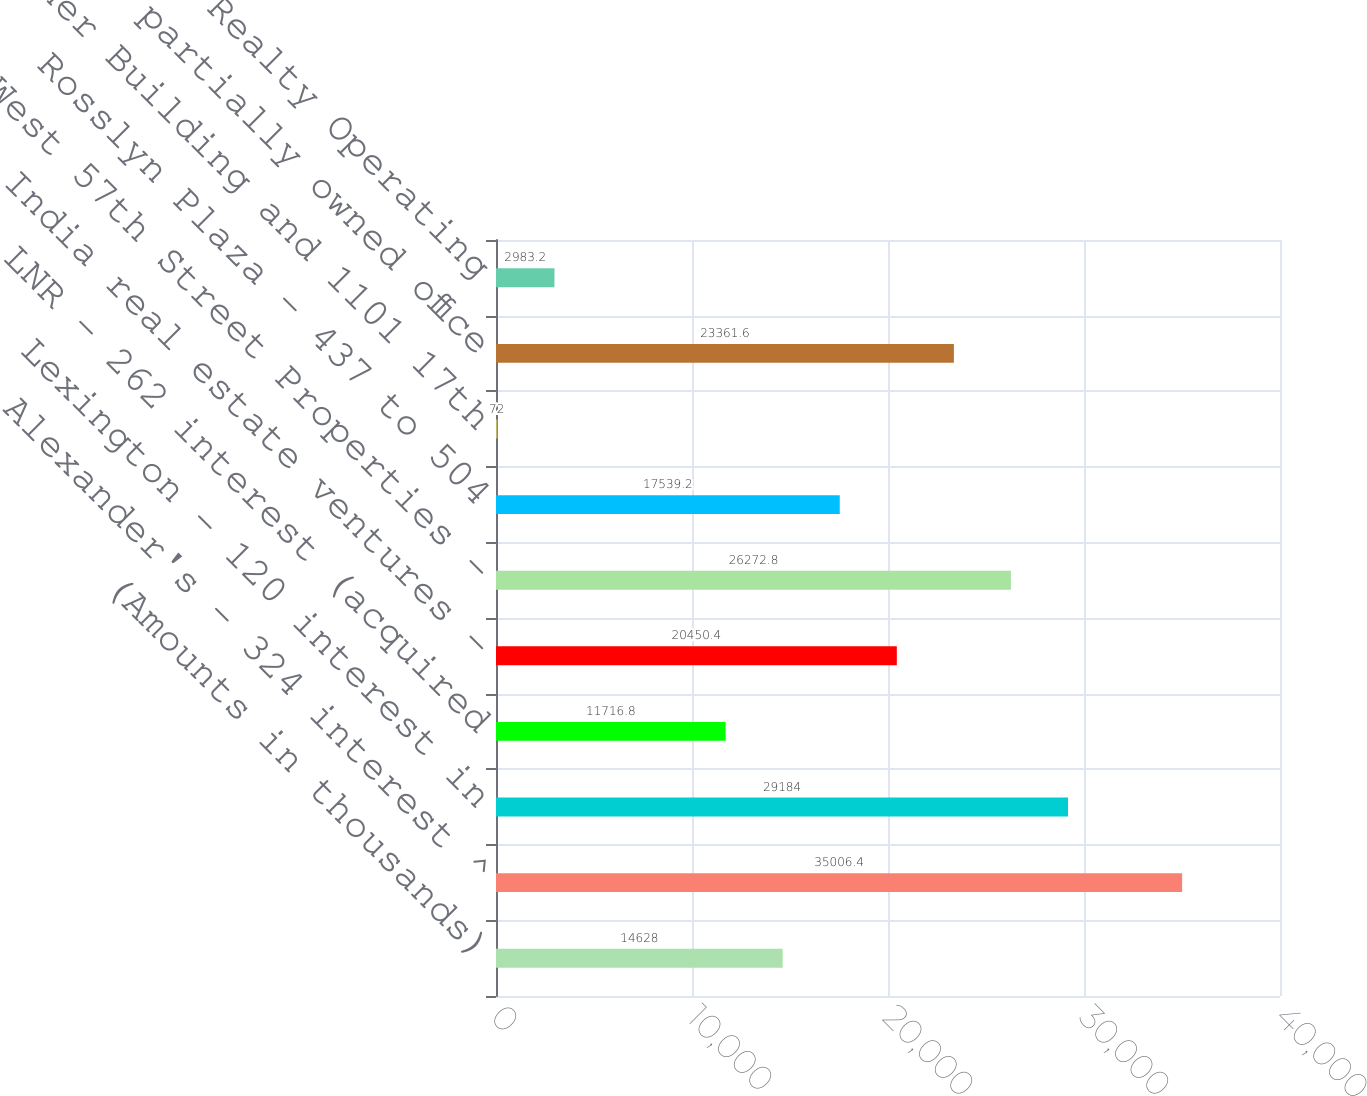Convert chart. <chart><loc_0><loc_0><loc_500><loc_500><bar_chart><fcel>(Amounts in thousands)<fcel>Alexander's - 324 interest ^<fcel>Lexington - 120 interest in<fcel>LNR - 262 interest (acquired<fcel>India real estate ventures -<fcel>West 57th Street Properties -<fcel>Rosslyn Plaza - 437 to 504<fcel>Warner Building and 1101 17th<fcel>Other partially owned office<fcel>Verde Realty Operating<nl><fcel>14628<fcel>35006.4<fcel>29184<fcel>11716.8<fcel>20450.4<fcel>26272.8<fcel>17539.2<fcel>72<fcel>23361.6<fcel>2983.2<nl></chart> 